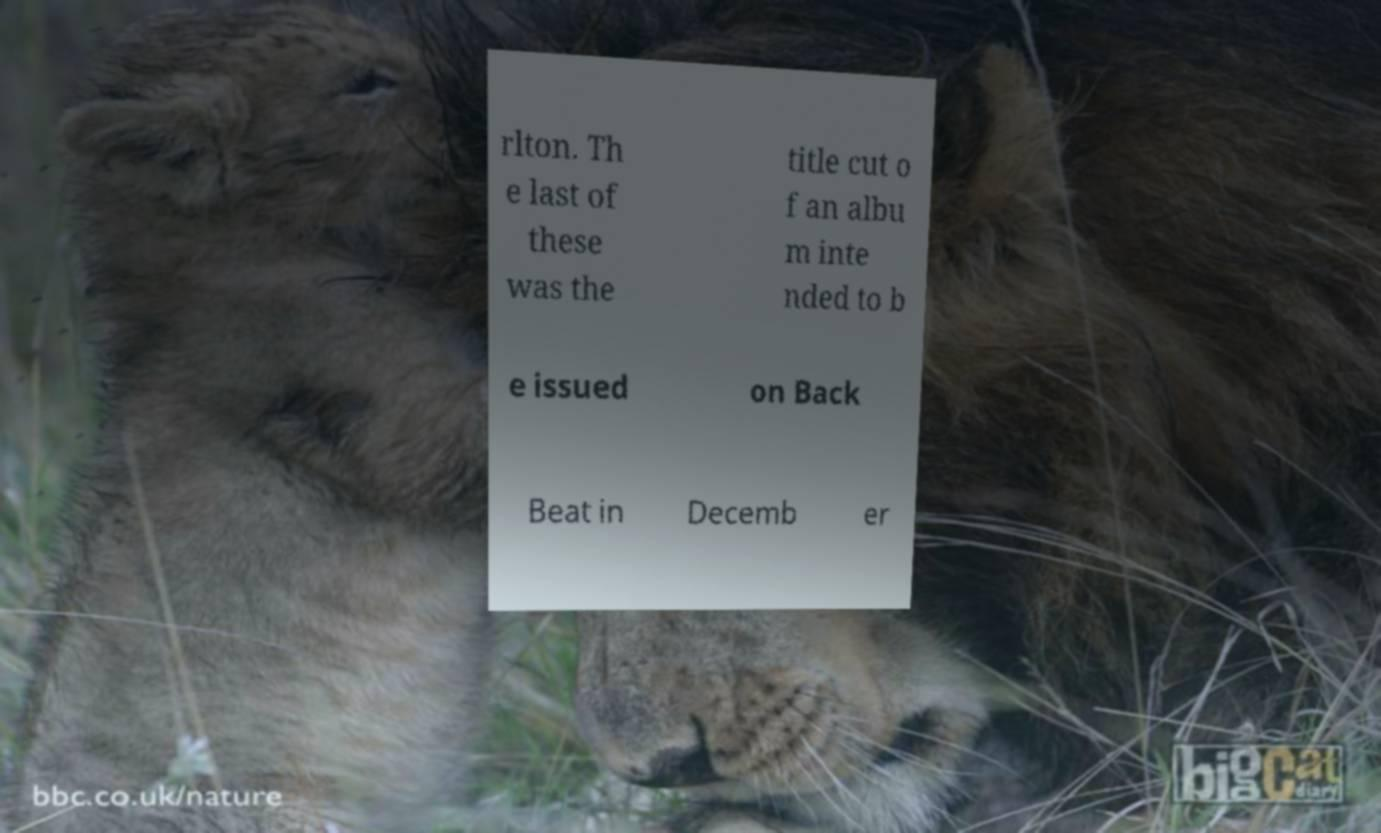What messages or text are displayed in this image? I need them in a readable, typed format. rlton. Th e last of these was the title cut o f an albu m inte nded to b e issued on Back Beat in Decemb er 